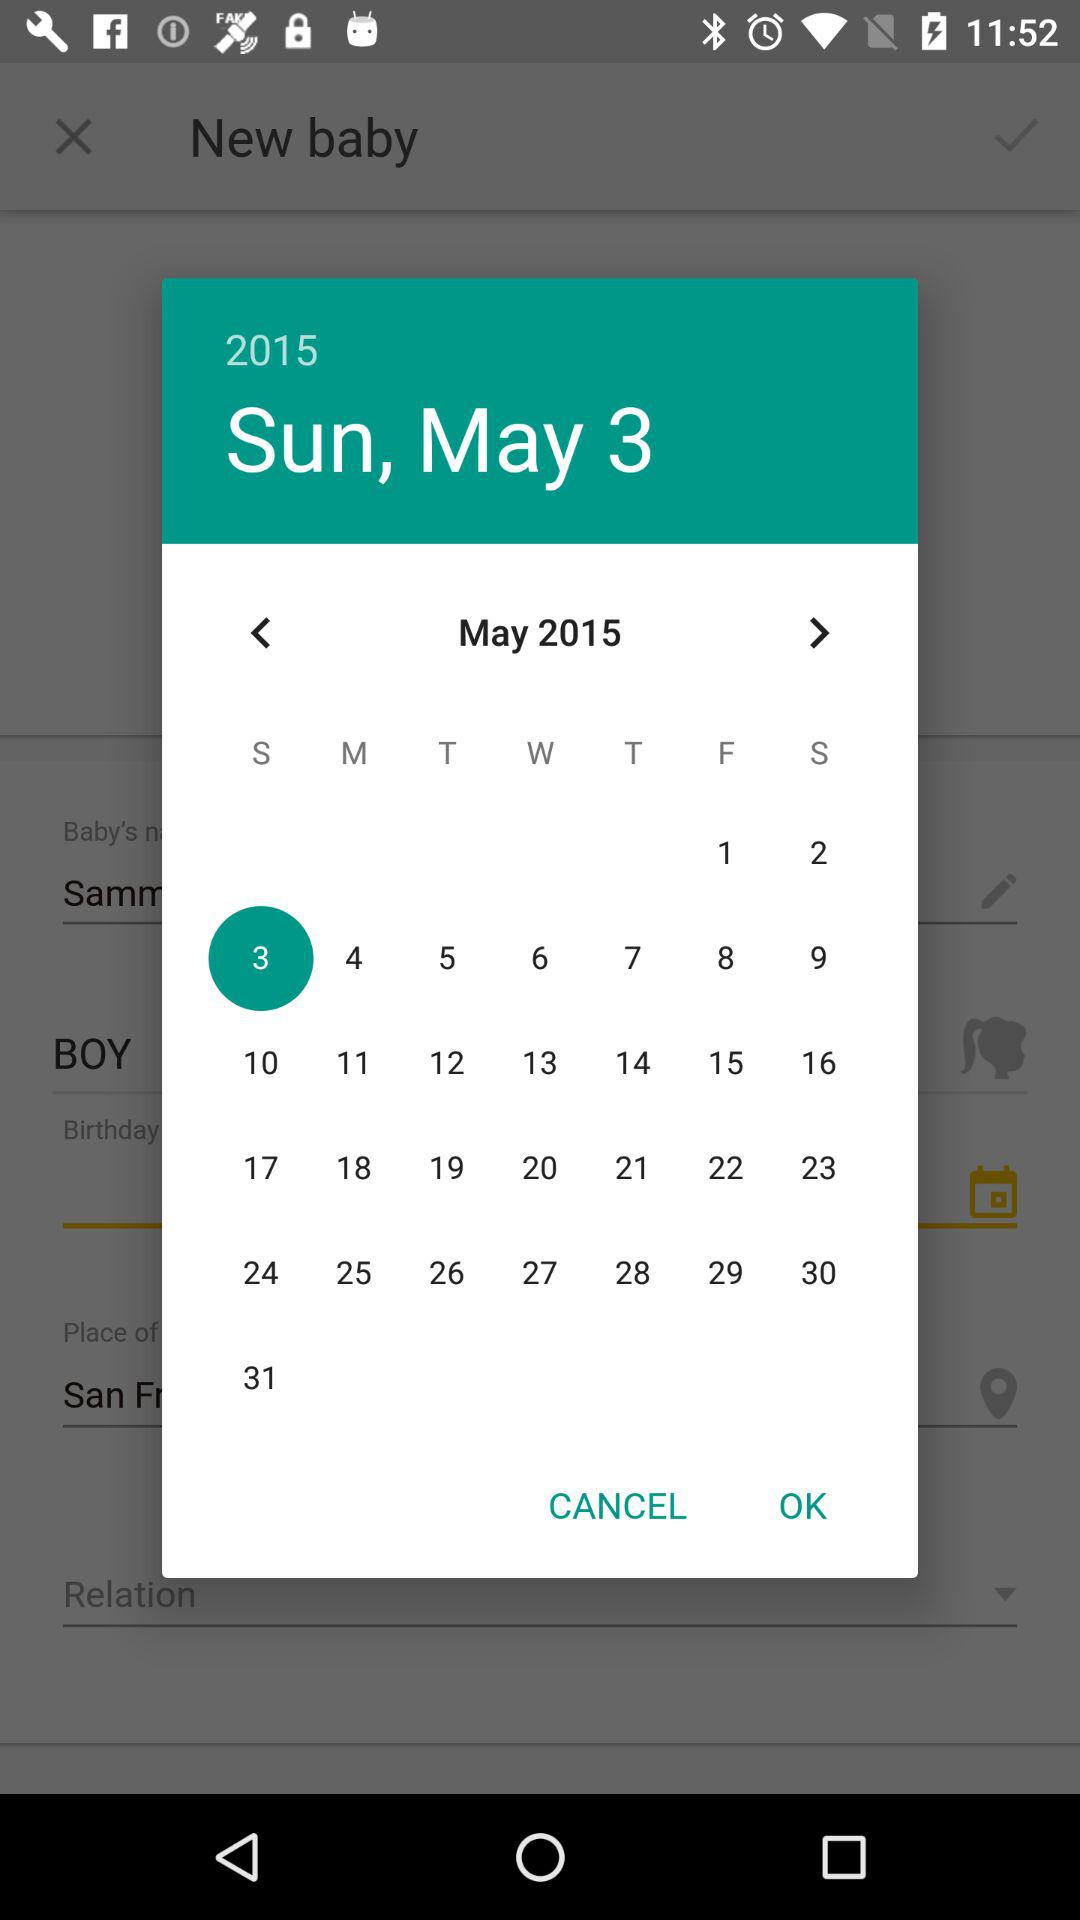What is the selected date? The selected date is Sunday, May 3, 2015. 